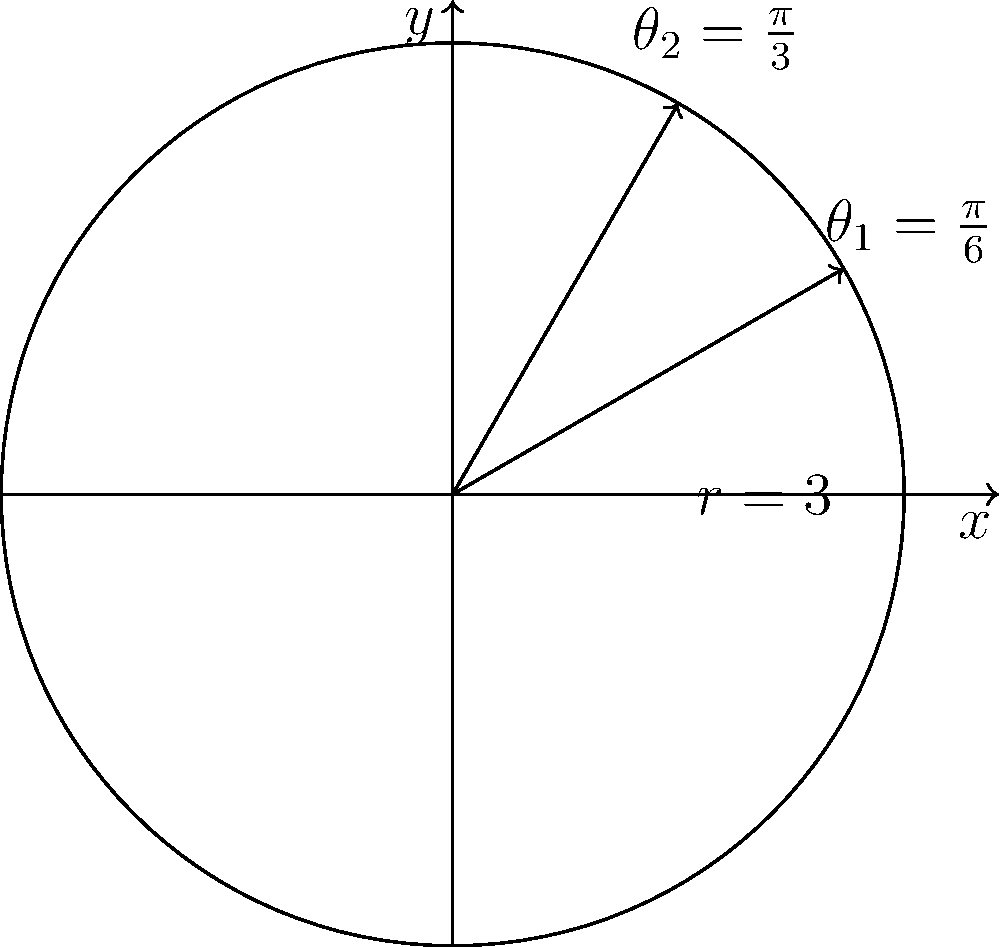A mobile money service has a circular coverage area with a radius of 3 km. Two customers are located at angles $\frac{\pi}{6}$ and $\frac{\pi}{3}$ radians from the positive x-axis. What is the straight-line distance between these two customers in kilometers? To find the distance between the two customers, we can follow these steps:

1) First, we need to convert the polar coordinates to Cartesian coordinates.

   For customer 1: $(r_1, \theta_1) = (3, \frac{\pi}{6})$
   $x_1 = r_1 \cos(\theta_1) = 3 \cos(\frac{\pi}{6}) = 3 \cdot \frac{\sqrt{3}}{2} = \frac{3\sqrt{3}}{2}$
   $y_1 = r_1 \sin(\theta_1) = 3 \sin(\frac{\pi}{6}) = 3 \cdot \frac{1}{2} = \frac{3}{2}$

   For customer 2: $(r_2, \theta_2) = (3, \frac{\pi}{3})$
   $x_2 = r_2 \cos(\theta_2) = 3 \cos(\frac{\pi}{3}) = 3 \cdot \frac{1}{2} = \frac{3}{2}$
   $y_2 = r_2 \sin(\theta_2) = 3 \sin(\frac{\pi}{3}) = 3 \cdot \frac{\sqrt{3}}{2} = \frac{3\sqrt{3}}{2}$

2) Now we can use the distance formula between two points:
   $d = \sqrt{(x_2-x_1)^2 + (y_2-y_1)^2}$

3) Substituting our values:
   $d = \sqrt{(\frac{3}{2}-\frac{3\sqrt{3}}{2})^2 + (\frac{3\sqrt{3}}{2}-\frac{3}{2})^2}$

4) Simplifying inside the parentheses:
   $d = \sqrt{(\frac{3-3\sqrt{3}}{2})^2 + (\frac{3\sqrt{3}-3}{2})^2}$

5) These are actually the same expression, so we can simplify:
   $d = \sqrt{2(\frac{3-3\sqrt{3}}{2})^2}$

6) Simplifying further:
   $d = \sqrt{2} \cdot \frac{3-3\sqrt{3}}{2} = \frac{3\sqrt{2}-3\sqrt{6}}{2}$

7) This can be further simplified:
   $d = 3(\frac{\sqrt{2}-\sqrt{6}}{2})$

Therefore, the distance between the two customers is $3(\frac{\sqrt{2}-\sqrt{6}}{2})$ km.
Answer: $3(\frac{\sqrt{2}-\sqrt{6}}{2})$ km 